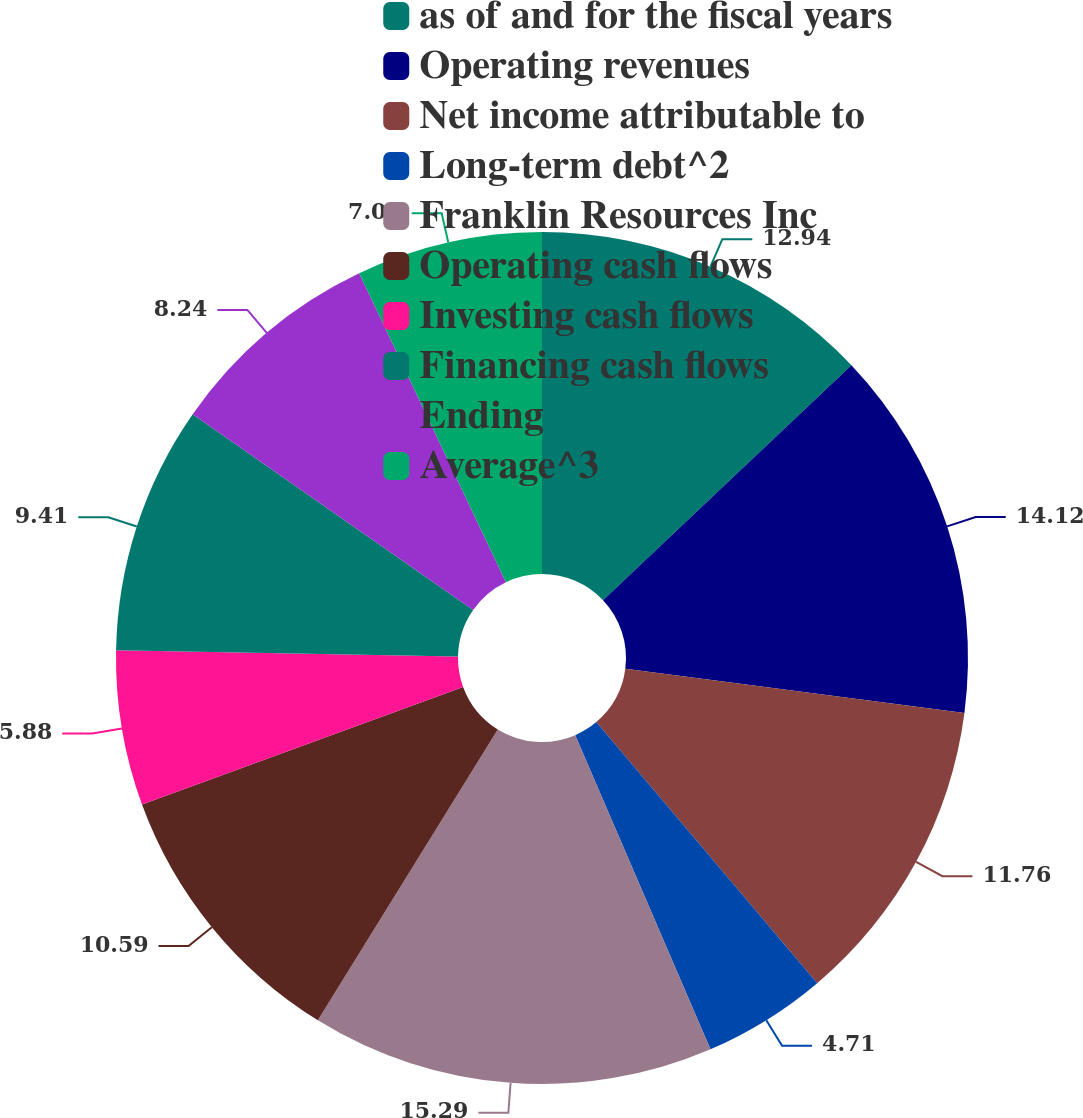Convert chart. <chart><loc_0><loc_0><loc_500><loc_500><pie_chart><fcel>as of and for the fiscal years<fcel>Operating revenues<fcel>Net income attributable to<fcel>Long-term debt^2<fcel>Franklin Resources Inc<fcel>Operating cash flows<fcel>Investing cash flows<fcel>Financing cash flows<fcel>Ending<fcel>Average^3<nl><fcel>12.94%<fcel>14.12%<fcel>11.76%<fcel>4.71%<fcel>15.29%<fcel>10.59%<fcel>5.88%<fcel>9.41%<fcel>8.24%<fcel>7.06%<nl></chart> 